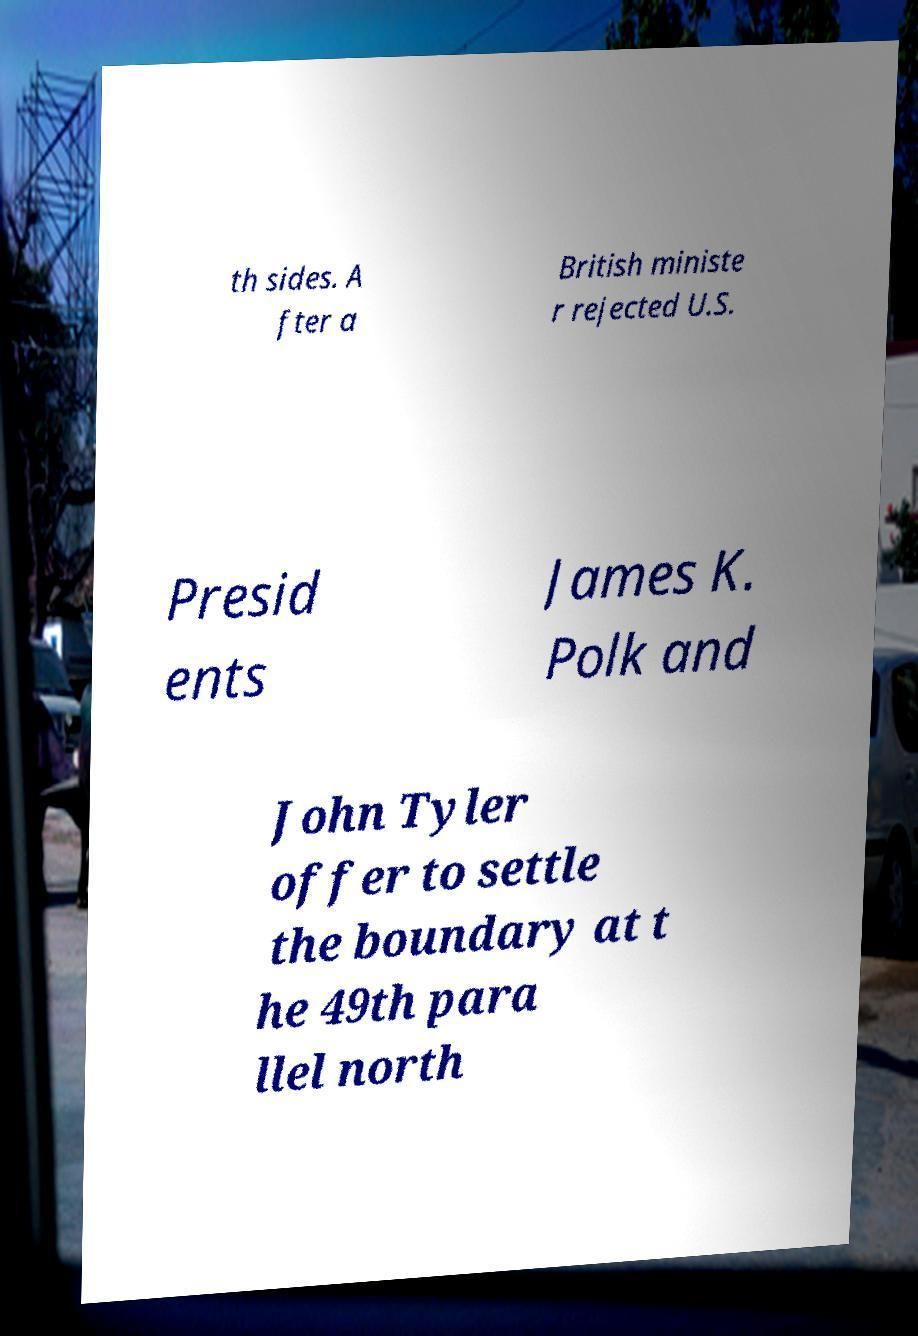Please identify and transcribe the text found in this image. th sides. A fter a British ministe r rejected U.S. Presid ents James K. Polk and John Tyler offer to settle the boundary at t he 49th para llel north 